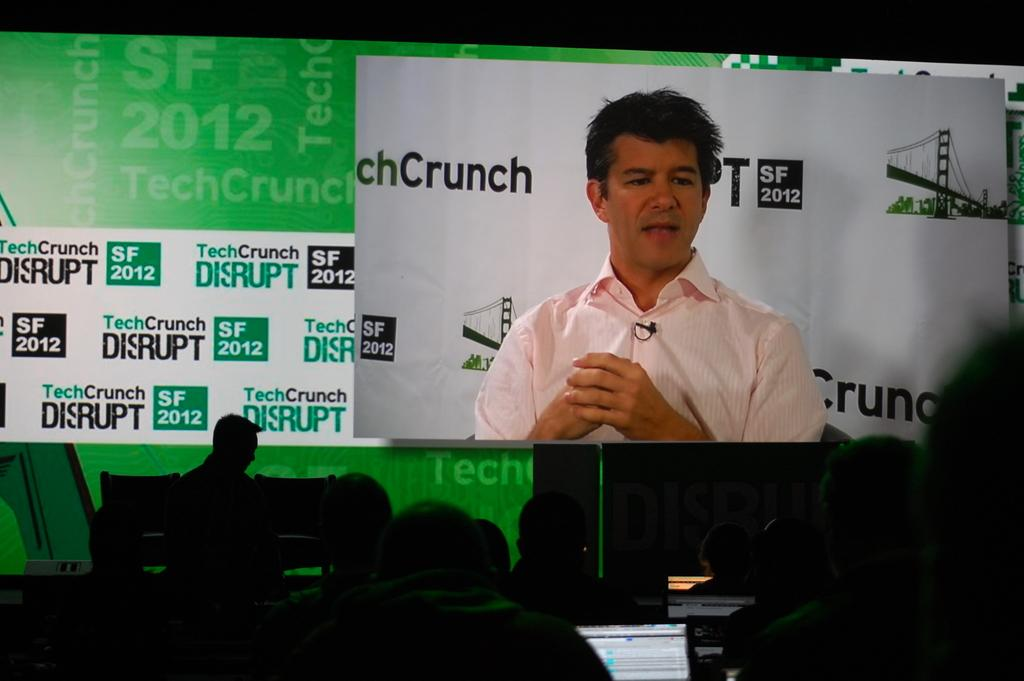What is the man in the image doing? The man is talking in the image. What can be seen in the background of the image? There is a banner in the background of the image. Who else is present in the image? There are people sitting at the bottom of the image. What object is located in the middle of the image? There is a laptop in the middle of the image. What type of dust can be seen on the laptop in the image? There is no dust visible on the laptop in the image. Can you recite a verse from the banner in the image? The content of the banner is not provided, so it is not possible to recite a verse from it. 